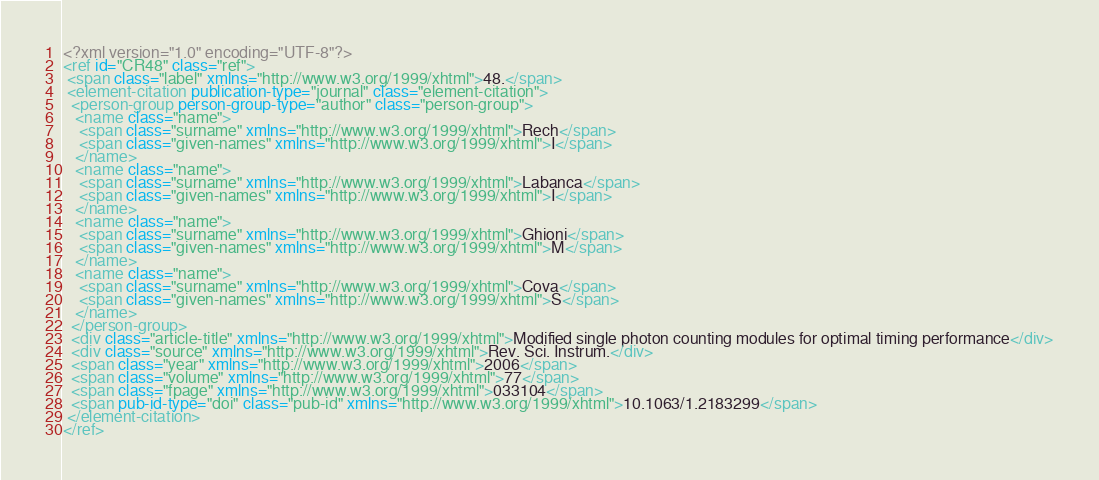<code> <loc_0><loc_0><loc_500><loc_500><_XML_><?xml version="1.0" encoding="UTF-8"?>
<ref id="CR48" class="ref">
 <span class="label" xmlns="http://www.w3.org/1999/xhtml">48.</span>
 <element-citation publication-type="journal" class="element-citation">
  <person-group person-group-type="author" class="person-group">
   <name class="name">
    <span class="surname" xmlns="http://www.w3.org/1999/xhtml">Rech</span>
    <span class="given-names" xmlns="http://www.w3.org/1999/xhtml">I</span>
   </name>
   <name class="name">
    <span class="surname" xmlns="http://www.w3.org/1999/xhtml">Labanca</span>
    <span class="given-names" xmlns="http://www.w3.org/1999/xhtml">I</span>
   </name>
   <name class="name">
    <span class="surname" xmlns="http://www.w3.org/1999/xhtml">Ghioni</span>
    <span class="given-names" xmlns="http://www.w3.org/1999/xhtml">M</span>
   </name>
   <name class="name">
    <span class="surname" xmlns="http://www.w3.org/1999/xhtml">Cova</span>
    <span class="given-names" xmlns="http://www.w3.org/1999/xhtml">S</span>
   </name>
  </person-group>
  <div class="article-title" xmlns="http://www.w3.org/1999/xhtml">Modified single photon counting modules for optimal timing performance</div>
  <div class="source" xmlns="http://www.w3.org/1999/xhtml">Rev. Sci. Instrum.</div>
  <span class="year" xmlns="http://www.w3.org/1999/xhtml">2006</span>
  <span class="volume" xmlns="http://www.w3.org/1999/xhtml">77</span>
  <span class="fpage" xmlns="http://www.w3.org/1999/xhtml">033104</span>
  <span pub-id-type="doi" class="pub-id" xmlns="http://www.w3.org/1999/xhtml">10.1063/1.2183299</span>
 </element-citation>
</ref>
</code> 